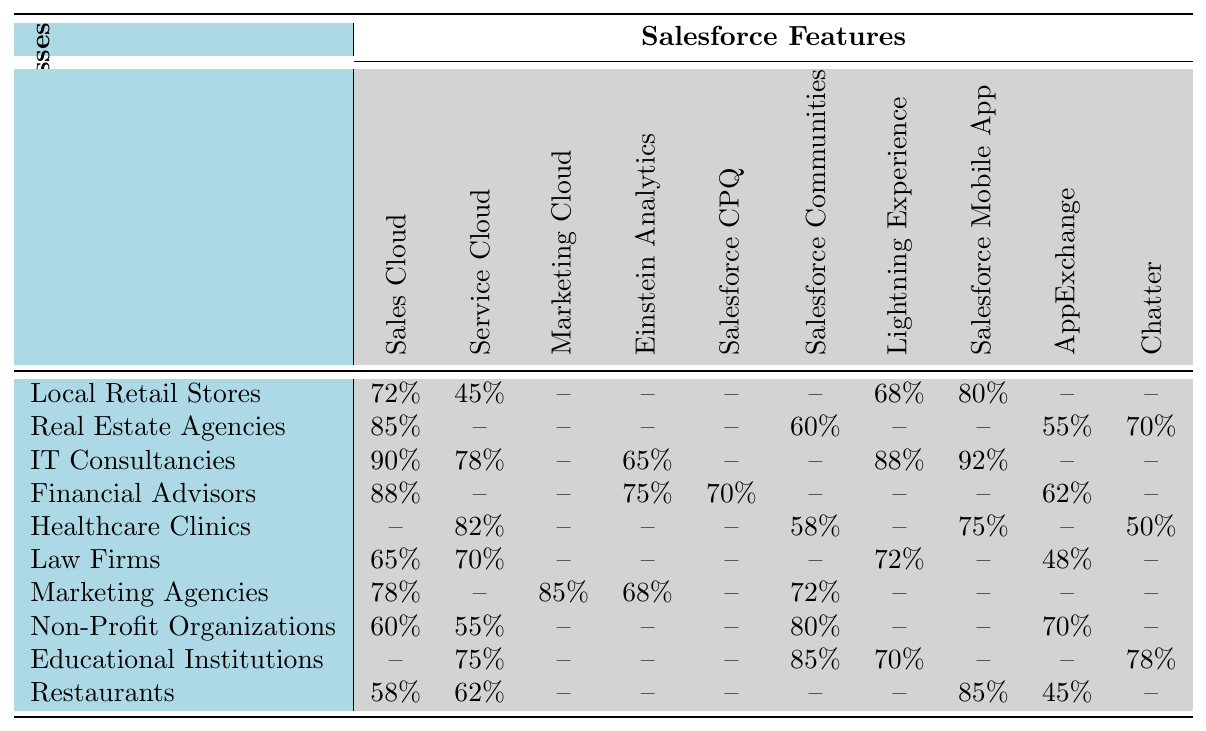What is the adoption rate of Sales Cloud among IT Consultancies? Looking at the adoption rates for IT Consultancies, the Sales Cloud adoption is listed as 90%.
Answer: 90% Which feature has the highest adoption rate among Healthcare Clinics? The feature with the highest adoption rate among Healthcare Clinics is Service Cloud, with an adoption rate of 82%.
Answer: 82% Do Local Retail Stores adopt the Marketing Cloud feature? No, Local Retail Stores do not have any adoption rate listed for the Marketing Cloud feature, which is indicated by the '--' in the table.
Answer: No What is the average adoption rate of Salesforce Mobile App among all listed businesses? The adoption rates for Salesforce Mobile App are: 80%, 92%, 75%, 85%. Summing these rates gives 332%, and dividing by 4 businesses gives an average of 83%.
Answer: 83% Which small business has the lowest adoption rate for Service Cloud, and what is that rate? The businesses listed for Service Cloud are: Local Retail Stores (45%), Healthcare Clinics (82%), Law Firms (70%), Financial Advisors (not listed), Non-Profit Organizations (55%), and Educational Institutions (75%). Local Retail Stores have the lowest rate at 45%.
Answer: 45% Is the adoption of Salesforce Communities higher than that of AppExchange for Educational Institutions? Yes, Educational Institutions have an adoption rate of 85% for Salesforce Communities, which is higher than the 70% adoption rate for AppExchange.
Answer: Yes How many features have an adoption rate of over 80% for Marketing Agencies? Marketing Agencies have three features with adoption rates over 80%: Sales Cloud (78%), Marketing Cloud (85%), and Salesforce Communities (72%). Thus, only one feature exceeds 80% adoption, which is Marketing Cloud.
Answer: 1 What is the difference in adoption rates between Salesforce CPQ and Chatter for Financial Advisors? Financial Advisors have an adoption rate of 70% for Salesforce CPQ and no adoption rate listed for Chatter (indicated by '--'), meaning the difference cannot be determined as Chatter is not adopted.
Answer: Not determinable Which feature is most commonly adopted by Local Retail Stores in comparison to Service Cloud? Among Local Retail Stores, the most commonly adopted feature is the Salesforce Mobile App with 80%, which is higher than the 45% adoption rate for Service Cloud.
Answer: Salesforce Mobile App Which small business has the highest overall number of adopted features from the table? IT Consultancies have five features with adoption (Sales Cloud, Service Cloud, Einstein Analytics, Lightning Experience, Salesforce Mobile App), which is the highest number of all small businesses mentioned.
Answer: IT Consultancies 